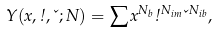<formula> <loc_0><loc_0><loc_500><loc_500>Y ( x , \omega , \kappa ; N ) = \sum x ^ { N _ { b } } \omega ^ { N _ { i m } } \kappa ^ { N _ { i b } } ,</formula> 